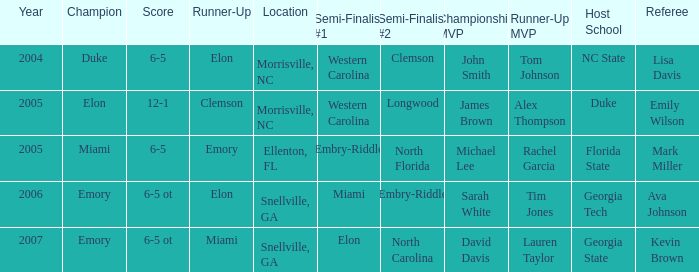List the scores of all games when Miami were listed as the first Semi finalist 6-5 ot. 